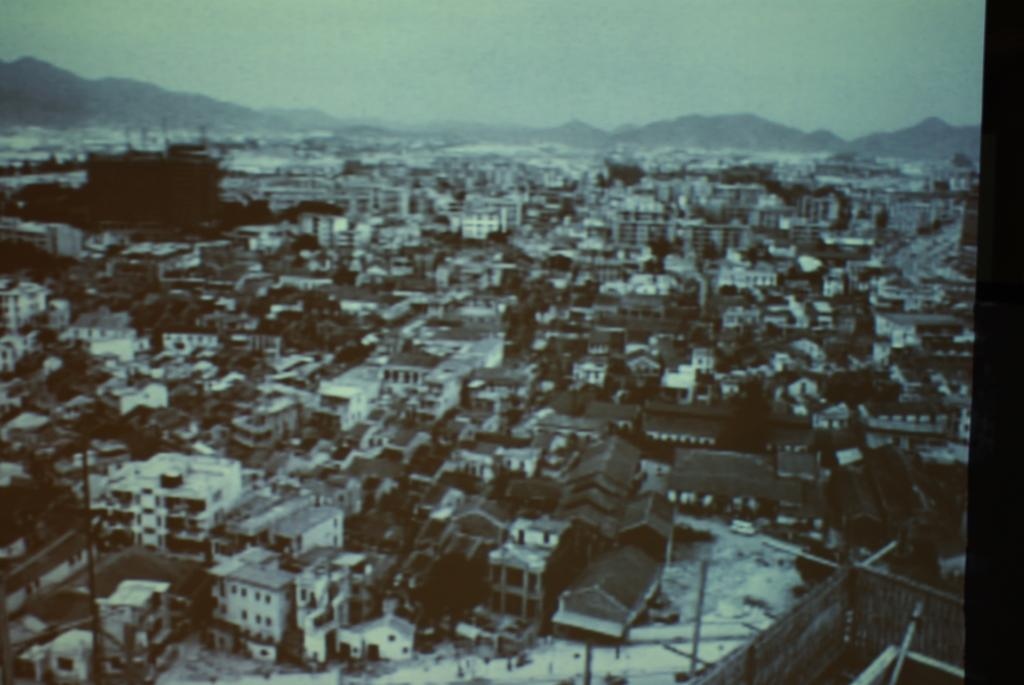What is the color scheme of the photograph? The photograph is black and white. What type of structures can be seen in the photograph? There are buildings in the photograph. What natural elements are present in the photograph? There are trees in the photograph. What man-made features can be seen in the photograph? There are roads, railings, and poles in the photograph. What geographical features are visible in the photograph? There are hills in the photograph. What part of the natural environment is visible in the photograph? The sky is visible in the photograph. How many cracks can be seen on the oven in the photograph? There is no oven present in the photograph, so it is not possible to determine the number of cracks on it. 